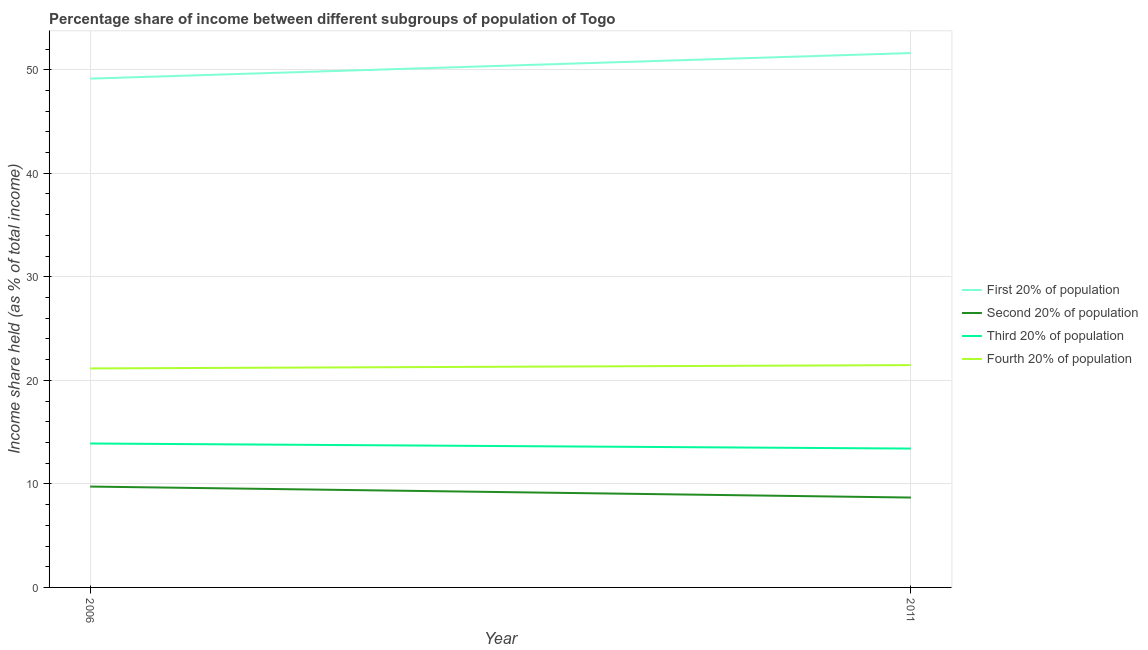What is the share of the income held by second 20% of the population in 2006?
Your answer should be compact. 9.74. Across all years, what is the maximum share of the income held by second 20% of the population?
Your answer should be very brief. 9.74. Across all years, what is the minimum share of the income held by first 20% of the population?
Ensure brevity in your answer.  49.14. What is the total share of the income held by second 20% of the population in the graph?
Your answer should be compact. 18.42. What is the difference between the share of the income held by first 20% of the population in 2006 and that in 2011?
Keep it short and to the point. -2.47. What is the difference between the share of the income held by third 20% of the population in 2011 and the share of the income held by fourth 20% of the population in 2006?
Your answer should be very brief. -7.74. What is the average share of the income held by first 20% of the population per year?
Give a very brief answer. 50.38. In the year 2011, what is the difference between the share of the income held by third 20% of the population and share of the income held by first 20% of the population?
Make the answer very short. -38.2. What is the ratio of the share of the income held by third 20% of the population in 2006 to that in 2011?
Keep it short and to the point. 1.04. In how many years, is the share of the income held by second 20% of the population greater than the average share of the income held by second 20% of the population taken over all years?
Your answer should be very brief. 1. Is it the case that in every year, the sum of the share of the income held by second 20% of the population and share of the income held by first 20% of the population is greater than the sum of share of the income held by fourth 20% of the population and share of the income held by third 20% of the population?
Give a very brief answer. Yes. Does the share of the income held by fourth 20% of the population monotonically increase over the years?
Your answer should be very brief. Yes. Is the share of the income held by second 20% of the population strictly greater than the share of the income held by first 20% of the population over the years?
Provide a succinct answer. No. How many lines are there?
Your answer should be very brief. 4. What is the difference between two consecutive major ticks on the Y-axis?
Make the answer very short. 10. Are the values on the major ticks of Y-axis written in scientific E-notation?
Your answer should be compact. No. Does the graph contain any zero values?
Give a very brief answer. No. Does the graph contain grids?
Keep it short and to the point. Yes. Where does the legend appear in the graph?
Give a very brief answer. Center right. How many legend labels are there?
Offer a terse response. 4. How are the legend labels stacked?
Make the answer very short. Vertical. What is the title of the graph?
Your response must be concise. Percentage share of income between different subgroups of population of Togo. What is the label or title of the X-axis?
Keep it short and to the point. Year. What is the label or title of the Y-axis?
Offer a very short reply. Income share held (as % of total income). What is the Income share held (as % of total income) in First 20% of population in 2006?
Keep it short and to the point. 49.14. What is the Income share held (as % of total income) in Second 20% of population in 2006?
Your answer should be compact. 9.74. What is the Income share held (as % of total income) of Third 20% of population in 2006?
Offer a very short reply. 13.9. What is the Income share held (as % of total income) in Fourth 20% of population in 2006?
Give a very brief answer. 21.15. What is the Income share held (as % of total income) in First 20% of population in 2011?
Provide a short and direct response. 51.61. What is the Income share held (as % of total income) of Second 20% of population in 2011?
Your response must be concise. 8.68. What is the Income share held (as % of total income) in Third 20% of population in 2011?
Offer a very short reply. 13.41. What is the Income share held (as % of total income) in Fourth 20% of population in 2011?
Give a very brief answer. 21.47. Across all years, what is the maximum Income share held (as % of total income) in First 20% of population?
Keep it short and to the point. 51.61. Across all years, what is the maximum Income share held (as % of total income) of Second 20% of population?
Offer a terse response. 9.74. Across all years, what is the maximum Income share held (as % of total income) in Third 20% of population?
Provide a succinct answer. 13.9. Across all years, what is the maximum Income share held (as % of total income) of Fourth 20% of population?
Keep it short and to the point. 21.47. Across all years, what is the minimum Income share held (as % of total income) of First 20% of population?
Give a very brief answer. 49.14. Across all years, what is the minimum Income share held (as % of total income) in Second 20% of population?
Offer a terse response. 8.68. Across all years, what is the minimum Income share held (as % of total income) of Third 20% of population?
Your answer should be compact. 13.41. Across all years, what is the minimum Income share held (as % of total income) of Fourth 20% of population?
Keep it short and to the point. 21.15. What is the total Income share held (as % of total income) of First 20% of population in the graph?
Ensure brevity in your answer.  100.75. What is the total Income share held (as % of total income) of Second 20% of population in the graph?
Your answer should be very brief. 18.42. What is the total Income share held (as % of total income) in Third 20% of population in the graph?
Give a very brief answer. 27.31. What is the total Income share held (as % of total income) in Fourth 20% of population in the graph?
Your response must be concise. 42.62. What is the difference between the Income share held (as % of total income) in First 20% of population in 2006 and that in 2011?
Give a very brief answer. -2.47. What is the difference between the Income share held (as % of total income) of Second 20% of population in 2006 and that in 2011?
Make the answer very short. 1.06. What is the difference between the Income share held (as % of total income) of Third 20% of population in 2006 and that in 2011?
Your response must be concise. 0.49. What is the difference between the Income share held (as % of total income) of Fourth 20% of population in 2006 and that in 2011?
Make the answer very short. -0.32. What is the difference between the Income share held (as % of total income) of First 20% of population in 2006 and the Income share held (as % of total income) of Second 20% of population in 2011?
Your answer should be compact. 40.46. What is the difference between the Income share held (as % of total income) of First 20% of population in 2006 and the Income share held (as % of total income) of Third 20% of population in 2011?
Keep it short and to the point. 35.73. What is the difference between the Income share held (as % of total income) of First 20% of population in 2006 and the Income share held (as % of total income) of Fourth 20% of population in 2011?
Offer a very short reply. 27.67. What is the difference between the Income share held (as % of total income) of Second 20% of population in 2006 and the Income share held (as % of total income) of Third 20% of population in 2011?
Offer a terse response. -3.67. What is the difference between the Income share held (as % of total income) in Second 20% of population in 2006 and the Income share held (as % of total income) in Fourth 20% of population in 2011?
Provide a short and direct response. -11.73. What is the difference between the Income share held (as % of total income) of Third 20% of population in 2006 and the Income share held (as % of total income) of Fourth 20% of population in 2011?
Offer a terse response. -7.57. What is the average Income share held (as % of total income) in First 20% of population per year?
Provide a succinct answer. 50.38. What is the average Income share held (as % of total income) in Second 20% of population per year?
Offer a very short reply. 9.21. What is the average Income share held (as % of total income) of Third 20% of population per year?
Give a very brief answer. 13.65. What is the average Income share held (as % of total income) in Fourth 20% of population per year?
Your response must be concise. 21.31. In the year 2006, what is the difference between the Income share held (as % of total income) of First 20% of population and Income share held (as % of total income) of Second 20% of population?
Your answer should be very brief. 39.4. In the year 2006, what is the difference between the Income share held (as % of total income) in First 20% of population and Income share held (as % of total income) in Third 20% of population?
Give a very brief answer. 35.24. In the year 2006, what is the difference between the Income share held (as % of total income) in First 20% of population and Income share held (as % of total income) in Fourth 20% of population?
Provide a succinct answer. 27.99. In the year 2006, what is the difference between the Income share held (as % of total income) in Second 20% of population and Income share held (as % of total income) in Third 20% of population?
Provide a succinct answer. -4.16. In the year 2006, what is the difference between the Income share held (as % of total income) of Second 20% of population and Income share held (as % of total income) of Fourth 20% of population?
Your response must be concise. -11.41. In the year 2006, what is the difference between the Income share held (as % of total income) in Third 20% of population and Income share held (as % of total income) in Fourth 20% of population?
Ensure brevity in your answer.  -7.25. In the year 2011, what is the difference between the Income share held (as % of total income) in First 20% of population and Income share held (as % of total income) in Second 20% of population?
Your response must be concise. 42.93. In the year 2011, what is the difference between the Income share held (as % of total income) of First 20% of population and Income share held (as % of total income) of Third 20% of population?
Your answer should be compact. 38.2. In the year 2011, what is the difference between the Income share held (as % of total income) of First 20% of population and Income share held (as % of total income) of Fourth 20% of population?
Offer a terse response. 30.14. In the year 2011, what is the difference between the Income share held (as % of total income) of Second 20% of population and Income share held (as % of total income) of Third 20% of population?
Your answer should be very brief. -4.73. In the year 2011, what is the difference between the Income share held (as % of total income) of Second 20% of population and Income share held (as % of total income) of Fourth 20% of population?
Your response must be concise. -12.79. In the year 2011, what is the difference between the Income share held (as % of total income) in Third 20% of population and Income share held (as % of total income) in Fourth 20% of population?
Provide a succinct answer. -8.06. What is the ratio of the Income share held (as % of total income) in First 20% of population in 2006 to that in 2011?
Your response must be concise. 0.95. What is the ratio of the Income share held (as % of total income) in Second 20% of population in 2006 to that in 2011?
Your answer should be compact. 1.12. What is the ratio of the Income share held (as % of total income) of Third 20% of population in 2006 to that in 2011?
Provide a short and direct response. 1.04. What is the ratio of the Income share held (as % of total income) in Fourth 20% of population in 2006 to that in 2011?
Ensure brevity in your answer.  0.99. What is the difference between the highest and the second highest Income share held (as % of total income) in First 20% of population?
Provide a succinct answer. 2.47. What is the difference between the highest and the second highest Income share held (as % of total income) of Second 20% of population?
Provide a succinct answer. 1.06. What is the difference between the highest and the second highest Income share held (as % of total income) in Third 20% of population?
Provide a succinct answer. 0.49. What is the difference between the highest and the second highest Income share held (as % of total income) of Fourth 20% of population?
Your answer should be compact. 0.32. What is the difference between the highest and the lowest Income share held (as % of total income) of First 20% of population?
Keep it short and to the point. 2.47. What is the difference between the highest and the lowest Income share held (as % of total income) in Second 20% of population?
Offer a terse response. 1.06. What is the difference between the highest and the lowest Income share held (as % of total income) of Third 20% of population?
Your answer should be very brief. 0.49. What is the difference between the highest and the lowest Income share held (as % of total income) of Fourth 20% of population?
Your answer should be very brief. 0.32. 